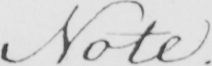Can you read and transcribe this handwriting? Note . 